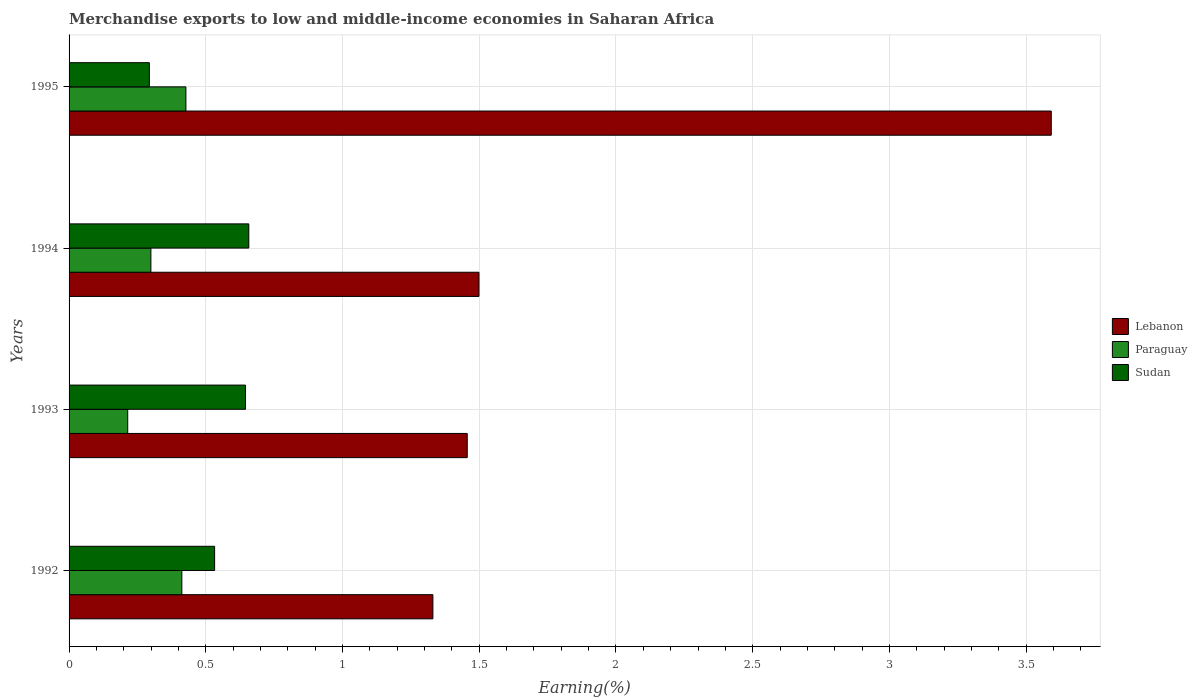How many groups of bars are there?
Your answer should be compact. 4. Are the number of bars per tick equal to the number of legend labels?
Offer a terse response. Yes. Are the number of bars on each tick of the Y-axis equal?
Provide a short and direct response. Yes. How many bars are there on the 2nd tick from the top?
Provide a short and direct response. 3. What is the label of the 4th group of bars from the top?
Offer a terse response. 1992. What is the percentage of amount earned from merchandise exports in Paraguay in 1994?
Offer a terse response. 0.3. Across all years, what is the maximum percentage of amount earned from merchandise exports in Lebanon?
Make the answer very short. 3.59. Across all years, what is the minimum percentage of amount earned from merchandise exports in Lebanon?
Provide a succinct answer. 1.33. In which year was the percentage of amount earned from merchandise exports in Sudan maximum?
Provide a succinct answer. 1994. What is the total percentage of amount earned from merchandise exports in Lebanon in the graph?
Provide a short and direct response. 7.88. What is the difference between the percentage of amount earned from merchandise exports in Lebanon in 1992 and that in 1993?
Your response must be concise. -0.13. What is the difference between the percentage of amount earned from merchandise exports in Sudan in 1992 and the percentage of amount earned from merchandise exports in Paraguay in 1994?
Give a very brief answer. 0.23. What is the average percentage of amount earned from merchandise exports in Lebanon per year?
Keep it short and to the point. 1.97. In the year 1994, what is the difference between the percentage of amount earned from merchandise exports in Paraguay and percentage of amount earned from merchandise exports in Sudan?
Make the answer very short. -0.36. What is the ratio of the percentage of amount earned from merchandise exports in Lebanon in 1993 to that in 1995?
Make the answer very short. 0.41. Is the percentage of amount earned from merchandise exports in Lebanon in 1992 less than that in 1993?
Give a very brief answer. Yes. What is the difference between the highest and the second highest percentage of amount earned from merchandise exports in Lebanon?
Your answer should be compact. 2.09. What is the difference between the highest and the lowest percentage of amount earned from merchandise exports in Lebanon?
Offer a very short reply. 2.26. In how many years, is the percentage of amount earned from merchandise exports in Sudan greater than the average percentage of amount earned from merchandise exports in Sudan taken over all years?
Offer a very short reply. 3. What does the 2nd bar from the top in 1994 represents?
Keep it short and to the point. Paraguay. What does the 3rd bar from the bottom in 1994 represents?
Provide a succinct answer. Sudan. Is it the case that in every year, the sum of the percentage of amount earned from merchandise exports in Paraguay and percentage of amount earned from merchandise exports in Lebanon is greater than the percentage of amount earned from merchandise exports in Sudan?
Your answer should be compact. Yes. How many bars are there?
Provide a short and direct response. 12. Are all the bars in the graph horizontal?
Offer a terse response. Yes. What is the difference between two consecutive major ticks on the X-axis?
Keep it short and to the point. 0.5. Are the values on the major ticks of X-axis written in scientific E-notation?
Give a very brief answer. No. Does the graph contain grids?
Keep it short and to the point. Yes. Where does the legend appear in the graph?
Your response must be concise. Center right. What is the title of the graph?
Keep it short and to the point. Merchandise exports to low and middle-income economies in Saharan Africa. Does "Barbados" appear as one of the legend labels in the graph?
Give a very brief answer. No. What is the label or title of the X-axis?
Provide a short and direct response. Earning(%). What is the label or title of the Y-axis?
Your answer should be very brief. Years. What is the Earning(%) in Lebanon in 1992?
Offer a terse response. 1.33. What is the Earning(%) of Paraguay in 1992?
Keep it short and to the point. 0.41. What is the Earning(%) of Sudan in 1992?
Offer a very short reply. 0.53. What is the Earning(%) in Lebanon in 1993?
Your response must be concise. 1.46. What is the Earning(%) of Paraguay in 1993?
Offer a terse response. 0.21. What is the Earning(%) of Sudan in 1993?
Your response must be concise. 0.65. What is the Earning(%) in Lebanon in 1994?
Your response must be concise. 1.5. What is the Earning(%) in Paraguay in 1994?
Provide a short and direct response. 0.3. What is the Earning(%) of Sudan in 1994?
Keep it short and to the point. 0.66. What is the Earning(%) of Lebanon in 1995?
Provide a short and direct response. 3.59. What is the Earning(%) in Paraguay in 1995?
Your response must be concise. 0.43. What is the Earning(%) of Sudan in 1995?
Ensure brevity in your answer.  0.29. Across all years, what is the maximum Earning(%) in Lebanon?
Give a very brief answer. 3.59. Across all years, what is the maximum Earning(%) of Paraguay?
Your answer should be very brief. 0.43. Across all years, what is the maximum Earning(%) of Sudan?
Give a very brief answer. 0.66. Across all years, what is the minimum Earning(%) in Lebanon?
Offer a terse response. 1.33. Across all years, what is the minimum Earning(%) in Paraguay?
Your response must be concise. 0.21. Across all years, what is the minimum Earning(%) in Sudan?
Ensure brevity in your answer.  0.29. What is the total Earning(%) of Lebanon in the graph?
Offer a terse response. 7.88. What is the total Earning(%) of Paraguay in the graph?
Ensure brevity in your answer.  1.35. What is the total Earning(%) in Sudan in the graph?
Ensure brevity in your answer.  2.13. What is the difference between the Earning(%) in Lebanon in 1992 and that in 1993?
Offer a terse response. -0.13. What is the difference between the Earning(%) in Paraguay in 1992 and that in 1993?
Provide a succinct answer. 0.2. What is the difference between the Earning(%) of Sudan in 1992 and that in 1993?
Your answer should be very brief. -0.11. What is the difference between the Earning(%) in Lebanon in 1992 and that in 1994?
Your answer should be compact. -0.17. What is the difference between the Earning(%) of Paraguay in 1992 and that in 1994?
Provide a short and direct response. 0.11. What is the difference between the Earning(%) of Sudan in 1992 and that in 1994?
Give a very brief answer. -0.13. What is the difference between the Earning(%) of Lebanon in 1992 and that in 1995?
Offer a very short reply. -2.26. What is the difference between the Earning(%) of Paraguay in 1992 and that in 1995?
Provide a short and direct response. -0.01. What is the difference between the Earning(%) of Sudan in 1992 and that in 1995?
Ensure brevity in your answer.  0.24. What is the difference between the Earning(%) of Lebanon in 1993 and that in 1994?
Offer a very short reply. -0.04. What is the difference between the Earning(%) in Paraguay in 1993 and that in 1994?
Give a very brief answer. -0.08. What is the difference between the Earning(%) of Sudan in 1993 and that in 1994?
Give a very brief answer. -0.01. What is the difference between the Earning(%) in Lebanon in 1993 and that in 1995?
Make the answer very short. -2.14. What is the difference between the Earning(%) of Paraguay in 1993 and that in 1995?
Your response must be concise. -0.21. What is the difference between the Earning(%) of Sudan in 1993 and that in 1995?
Your response must be concise. 0.35. What is the difference between the Earning(%) in Lebanon in 1994 and that in 1995?
Make the answer very short. -2.09. What is the difference between the Earning(%) of Paraguay in 1994 and that in 1995?
Provide a succinct answer. -0.13. What is the difference between the Earning(%) of Sudan in 1994 and that in 1995?
Keep it short and to the point. 0.36. What is the difference between the Earning(%) in Lebanon in 1992 and the Earning(%) in Paraguay in 1993?
Provide a short and direct response. 1.12. What is the difference between the Earning(%) in Lebanon in 1992 and the Earning(%) in Sudan in 1993?
Give a very brief answer. 0.69. What is the difference between the Earning(%) in Paraguay in 1992 and the Earning(%) in Sudan in 1993?
Make the answer very short. -0.23. What is the difference between the Earning(%) of Lebanon in 1992 and the Earning(%) of Paraguay in 1994?
Your answer should be compact. 1.03. What is the difference between the Earning(%) of Lebanon in 1992 and the Earning(%) of Sudan in 1994?
Your response must be concise. 0.67. What is the difference between the Earning(%) in Paraguay in 1992 and the Earning(%) in Sudan in 1994?
Keep it short and to the point. -0.24. What is the difference between the Earning(%) of Lebanon in 1992 and the Earning(%) of Paraguay in 1995?
Keep it short and to the point. 0.9. What is the difference between the Earning(%) of Lebanon in 1992 and the Earning(%) of Sudan in 1995?
Provide a short and direct response. 1.04. What is the difference between the Earning(%) in Paraguay in 1992 and the Earning(%) in Sudan in 1995?
Provide a succinct answer. 0.12. What is the difference between the Earning(%) in Lebanon in 1993 and the Earning(%) in Paraguay in 1994?
Ensure brevity in your answer.  1.16. What is the difference between the Earning(%) of Lebanon in 1993 and the Earning(%) of Sudan in 1994?
Your answer should be compact. 0.8. What is the difference between the Earning(%) of Paraguay in 1993 and the Earning(%) of Sudan in 1994?
Offer a very short reply. -0.44. What is the difference between the Earning(%) of Lebanon in 1993 and the Earning(%) of Paraguay in 1995?
Offer a terse response. 1.03. What is the difference between the Earning(%) of Lebanon in 1993 and the Earning(%) of Sudan in 1995?
Your answer should be compact. 1.16. What is the difference between the Earning(%) in Paraguay in 1993 and the Earning(%) in Sudan in 1995?
Your response must be concise. -0.08. What is the difference between the Earning(%) of Lebanon in 1994 and the Earning(%) of Paraguay in 1995?
Provide a short and direct response. 1.07. What is the difference between the Earning(%) of Lebanon in 1994 and the Earning(%) of Sudan in 1995?
Make the answer very short. 1.21. What is the difference between the Earning(%) in Paraguay in 1994 and the Earning(%) in Sudan in 1995?
Give a very brief answer. 0.01. What is the average Earning(%) of Lebanon per year?
Give a very brief answer. 1.97. What is the average Earning(%) in Paraguay per year?
Your answer should be compact. 0.34. What is the average Earning(%) in Sudan per year?
Keep it short and to the point. 0.53. In the year 1992, what is the difference between the Earning(%) in Lebanon and Earning(%) in Paraguay?
Your answer should be compact. 0.92. In the year 1992, what is the difference between the Earning(%) in Lebanon and Earning(%) in Sudan?
Your response must be concise. 0.8. In the year 1992, what is the difference between the Earning(%) of Paraguay and Earning(%) of Sudan?
Ensure brevity in your answer.  -0.12. In the year 1993, what is the difference between the Earning(%) of Lebanon and Earning(%) of Paraguay?
Give a very brief answer. 1.24. In the year 1993, what is the difference between the Earning(%) in Lebanon and Earning(%) in Sudan?
Offer a very short reply. 0.81. In the year 1993, what is the difference between the Earning(%) of Paraguay and Earning(%) of Sudan?
Make the answer very short. -0.43. In the year 1994, what is the difference between the Earning(%) of Lebanon and Earning(%) of Paraguay?
Offer a very short reply. 1.2. In the year 1994, what is the difference between the Earning(%) of Lebanon and Earning(%) of Sudan?
Give a very brief answer. 0.84. In the year 1994, what is the difference between the Earning(%) in Paraguay and Earning(%) in Sudan?
Provide a succinct answer. -0.36. In the year 1995, what is the difference between the Earning(%) in Lebanon and Earning(%) in Paraguay?
Make the answer very short. 3.16. In the year 1995, what is the difference between the Earning(%) of Lebanon and Earning(%) of Sudan?
Your answer should be compact. 3.3. In the year 1995, what is the difference between the Earning(%) of Paraguay and Earning(%) of Sudan?
Your response must be concise. 0.13. What is the ratio of the Earning(%) of Lebanon in 1992 to that in 1993?
Provide a succinct answer. 0.91. What is the ratio of the Earning(%) of Paraguay in 1992 to that in 1993?
Provide a short and direct response. 1.92. What is the ratio of the Earning(%) in Sudan in 1992 to that in 1993?
Offer a terse response. 0.82. What is the ratio of the Earning(%) of Lebanon in 1992 to that in 1994?
Your response must be concise. 0.89. What is the ratio of the Earning(%) of Paraguay in 1992 to that in 1994?
Your answer should be very brief. 1.38. What is the ratio of the Earning(%) in Sudan in 1992 to that in 1994?
Your response must be concise. 0.81. What is the ratio of the Earning(%) in Lebanon in 1992 to that in 1995?
Provide a short and direct response. 0.37. What is the ratio of the Earning(%) in Paraguay in 1992 to that in 1995?
Give a very brief answer. 0.97. What is the ratio of the Earning(%) in Sudan in 1992 to that in 1995?
Provide a short and direct response. 1.81. What is the ratio of the Earning(%) of Lebanon in 1993 to that in 1994?
Ensure brevity in your answer.  0.97. What is the ratio of the Earning(%) in Paraguay in 1993 to that in 1994?
Provide a succinct answer. 0.72. What is the ratio of the Earning(%) in Sudan in 1993 to that in 1994?
Ensure brevity in your answer.  0.98. What is the ratio of the Earning(%) of Lebanon in 1993 to that in 1995?
Make the answer very short. 0.41. What is the ratio of the Earning(%) in Paraguay in 1993 to that in 1995?
Keep it short and to the point. 0.5. What is the ratio of the Earning(%) of Sudan in 1993 to that in 1995?
Ensure brevity in your answer.  2.2. What is the ratio of the Earning(%) of Lebanon in 1994 to that in 1995?
Make the answer very short. 0.42. What is the ratio of the Earning(%) in Paraguay in 1994 to that in 1995?
Your response must be concise. 0.7. What is the ratio of the Earning(%) in Sudan in 1994 to that in 1995?
Offer a very short reply. 2.24. What is the difference between the highest and the second highest Earning(%) of Lebanon?
Keep it short and to the point. 2.09. What is the difference between the highest and the second highest Earning(%) in Paraguay?
Provide a succinct answer. 0.01. What is the difference between the highest and the second highest Earning(%) of Sudan?
Give a very brief answer. 0.01. What is the difference between the highest and the lowest Earning(%) in Lebanon?
Your response must be concise. 2.26. What is the difference between the highest and the lowest Earning(%) of Paraguay?
Provide a succinct answer. 0.21. What is the difference between the highest and the lowest Earning(%) of Sudan?
Keep it short and to the point. 0.36. 